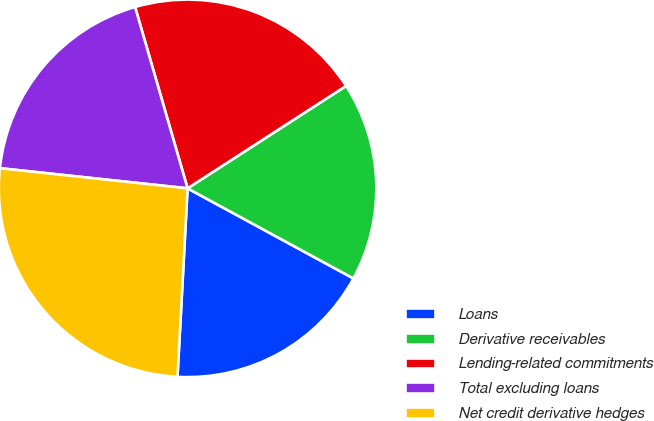Convert chart. <chart><loc_0><loc_0><loc_500><loc_500><pie_chart><fcel>Loans<fcel>Derivative receivables<fcel>Lending-related commitments<fcel>Total excluding loans<fcel>Net credit derivative hedges<nl><fcel>17.93%<fcel>17.05%<fcel>20.35%<fcel>18.81%<fcel>25.85%<nl></chart> 